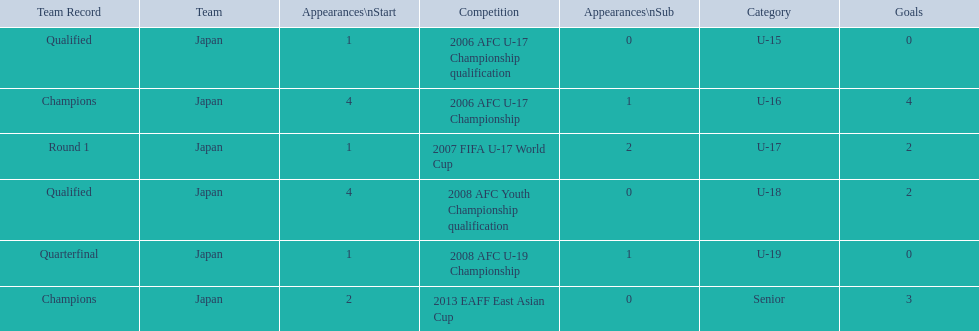What was the team record in 2006? Round 1. What competition did this belong too? 2006 AFC U-17 Championship. 